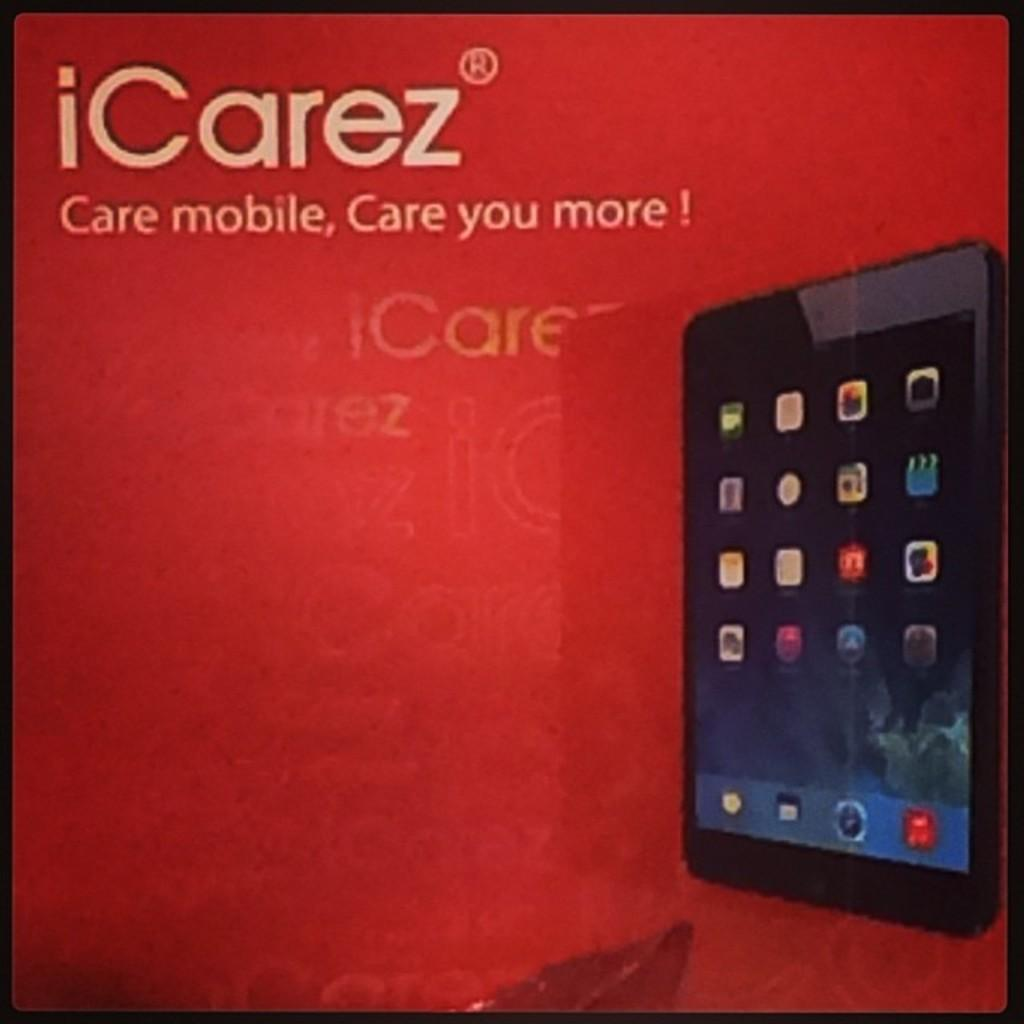What is the main subject of the image? The main subject of the image is a picture of a mobile. Are there any words or letters visible in the image? Yes, there is text or writing visible in the image. Where is the dock located in the image? There is no dock present in the image. What type of salt can be seen on the mobile in the image? There is no salt present in the image, and the mobile is a picture, not a physical object. 